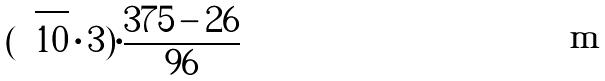Convert formula to latex. <formula><loc_0><loc_0><loc_500><loc_500>( \sqrt { 1 0 } \cdot 3 ) \cdot \frac { 3 7 5 - 2 6 } { 9 6 }</formula> 